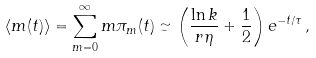Convert formula to latex. <formula><loc_0><loc_0><loc_500><loc_500>\langle m ( t ) \rangle = \sum _ { m = 0 } ^ { \infty } m \pi _ { m } ( t ) \simeq \left ( \frac { \ln k } { r \eta } + \frac { 1 } { 2 } \right ) e ^ { - t / \tau } \, ,</formula> 